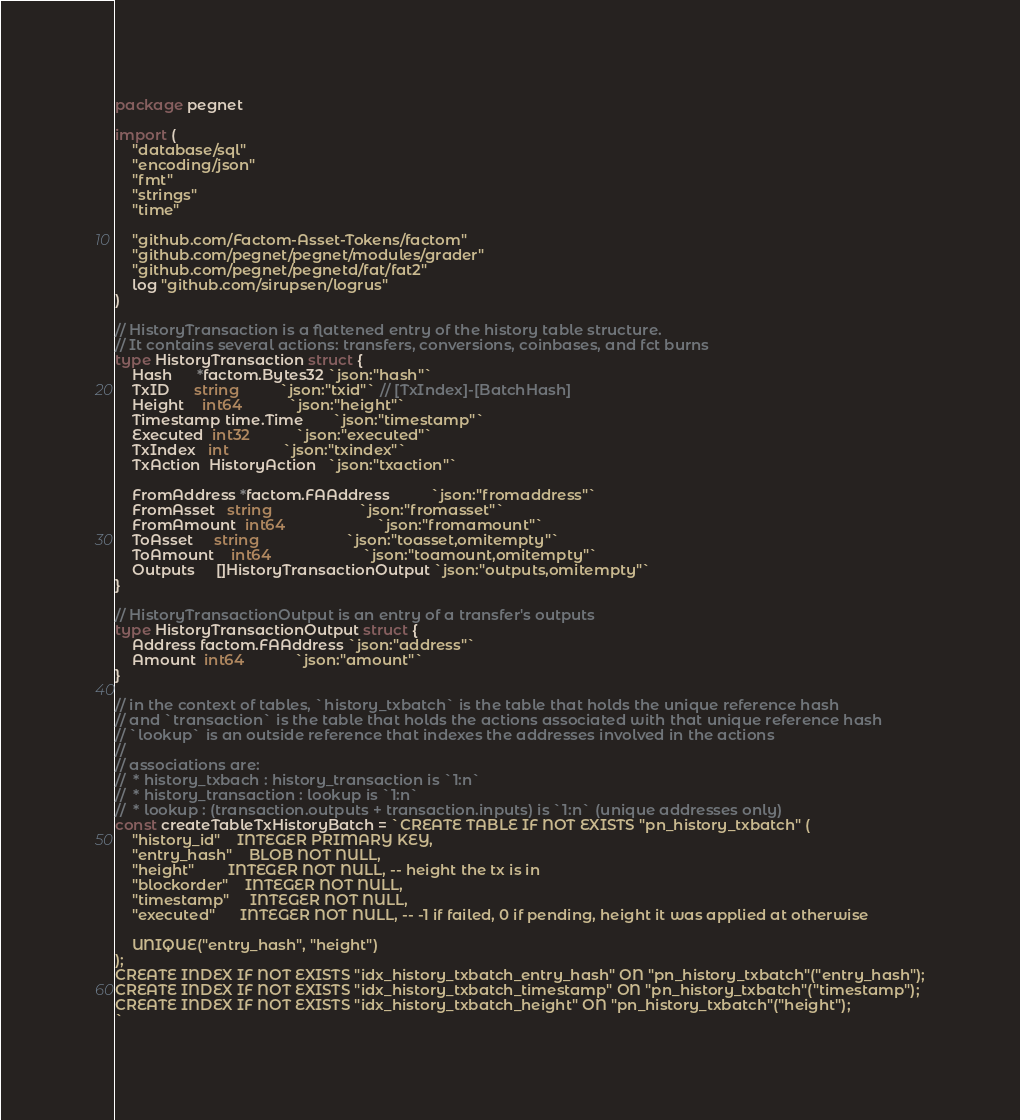Convert code to text. <code><loc_0><loc_0><loc_500><loc_500><_Go_>package pegnet

import (
	"database/sql"
	"encoding/json"
	"fmt"
	"strings"
	"time"

	"github.com/Factom-Asset-Tokens/factom"
	"github.com/pegnet/pegnet/modules/grader"
	"github.com/pegnet/pegnetd/fat/fat2"
	log "github.com/sirupsen/logrus"
)

// HistoryTransaction is a flattened entry of the history table structure.
// It contains several actions: transfers, conversions, coinbases, and fct burns
type HistoryTransaction struct {
	Hash      *factom.Bytes32 `json:"hash"`
	TxID      string          `json:"txid"` // [TxIndex]-[BatchHash]
	Height    int64           `json:"height"`
	Timestamp time.Time       `json:"timestamp"`
	Executed  int32           `json:"executed"`
	TxIndex   int             `json:"txindex"`
	TxAction  HistoryAction   `json:"txaction"`

	FromAddress *factom.FAAddress          `json:"fromaddress"`
	FromAsset   string                     `json:"fromasset"`
	FromAmount  int64                      `json:"fromamount"`
	ToAsset     string                     `json:"toasset,omitempty"`
	ToAmount    int64                      `json:"toamount,omitempty"`
	Outputs     []HistoryTransactionOutput `json:"outputs,omitempty"`
}

// HistoryTransactionOutput is an entry of a transfer's outputs
type HistoryTransactionOutput struct {
	Address factom.FAAddress `json:"address"`
	Amount  int64            `json:"amount"`
}

// in the context of tables, `history_txbatch` is the table that holds the unique reference hash
// and `transaction` is the table that holds the actions associated with that unique reference hash
// `lookup` is an outside reference that indexes the addresses involved in the actions
//
// associations are:
// 	* history_txbach : history_transaction is `1:n`
// 	* history_transaction : lookup is `1:n`
//	* lookup : (transaction.outputs + transaction.inputs) is `1:n` (unique addresses only)
const createTableTxHistoryBatch = `CREATE TABLE IF NOT EXISTS "pn_history_txbatch" (
	"history_id"	INTEGER PRIMARY KEY,
	"entry_hash"    BLOB NOT NULL,
	"height"        INTEGER NOT NULL, -- height the tx is in
	"blockorder"	INTEGER NOT NULL,
	"timestamp"		INTEGER NOT NULL,
	"executed"		INTEGER NOT NULL, -- -1 if failed, 0 if pending, height it was applied at otherwise

	UNIQUE("entry_hash", "height")
);
CREATE INDEX IF NOT EXISTS "idx_history_txbatch_entry_hash" ON "pn_history_txbatch"("entry_hash");
CREATE INDEX IF NOT EXISTS "idx_history_txbatch_timestamp" ON "pn_history_txbatch"("timestamp");
CREATE INDEX IF NOT EXISTS "idx_history_txbatch_height" ON "pn_history_txbatch"("height");
`
</code> 